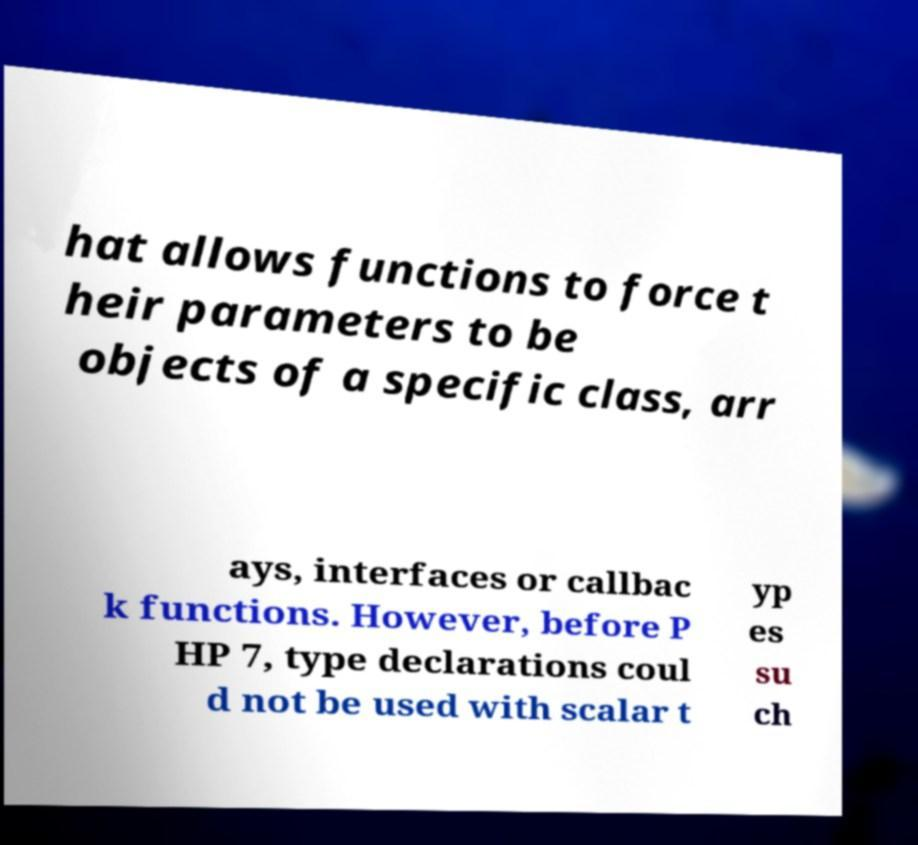There's text embedded in this image that I need extracted. Can you transcribe it verbatim? hat allows functions to force t heir parameters to be objects of a specific class, arr ays, interfaces or callbac k functions. However, before P HP 7, type declarations coul d not be used with scalar t yp es su ch 